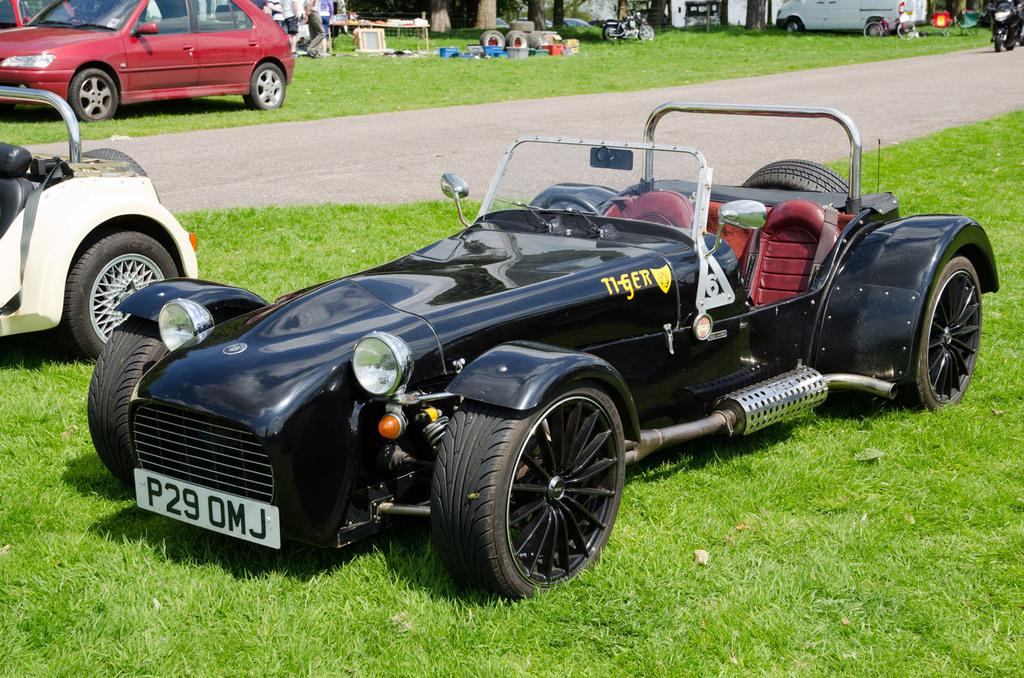What is the main setting of the image? The main setting of the image is a grassland. What can be seen in the middle of the grassland? There is a path in the middle of the image. What is happening in the background of the image? There are people standing in the background of the image. Can you describe any objects present in the image? Yes, there are objects present in the image. What role is the actor playing in the image? There is no actor present in the image; it features vehicles on a grassland, a path, and people in the background. Can you hear any sounds coming from the sidewalk in the image? There is no sidewalk present in the image, and therefore no sounds can be heard from it. 